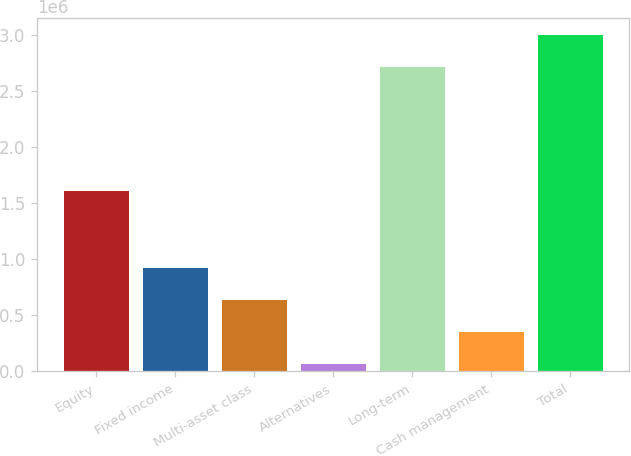<chart> <loc_0><loc_0><loc_500><loc_500><bar_chart><fcel>Equity<fcel>Fixed income<fcel>Multi-asset class<fcel>Alternatives<fcel>Long-term<fcel>Cash management<fcel>Total<nl><fcel>1.61078e+06<fcel>922259<fcel>634720<fcel>59644<fcel>2.71158e+06<fcel>347182<fcel>2.99912e+06<nl></chart> 